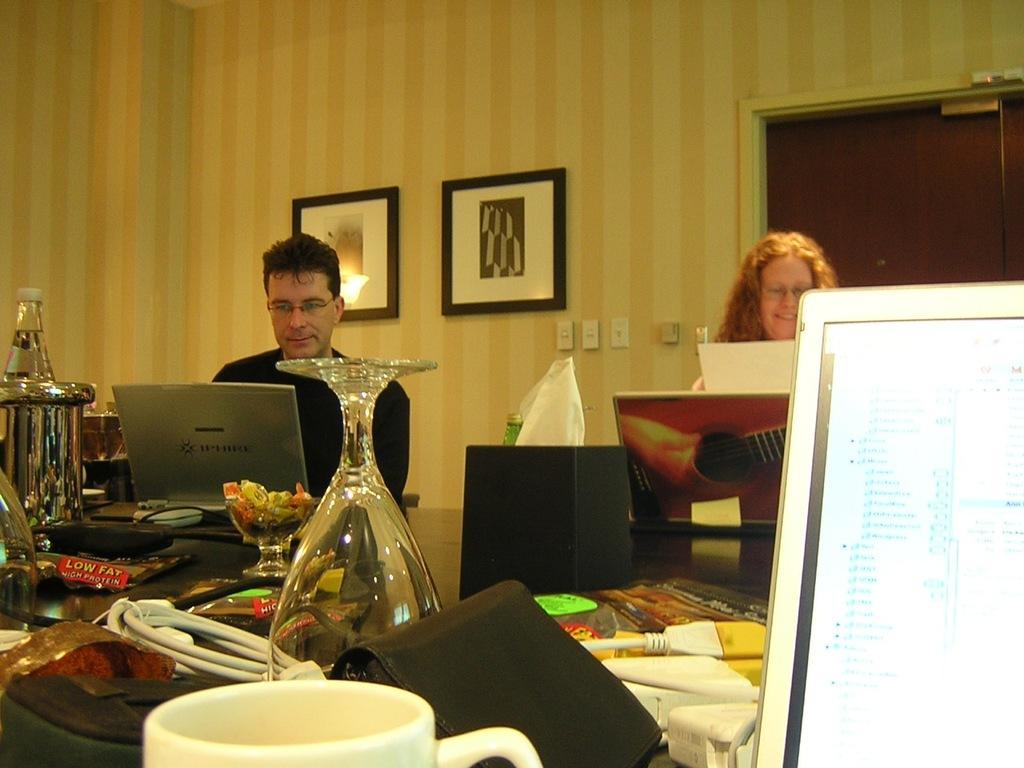Please provide a concise description of this image. The image is taken in the room. There are two people sitting. In the center of the image there is table. On the table there is a glass, jug, wallet, mug and some wires. In the background there is a wall frame and a door. 